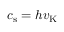<formula> <loc_0><loc_0><loc_500><loc_500>c _ { s } = h v _ { K }</formula> 